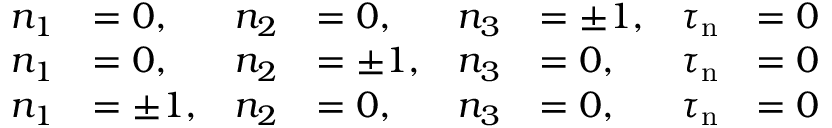Convert formula to latex. <formula><loc_0><loc_0><loc_500><loc_500>{ \begin{array} { r l r l r l r l } { n _ { 1 } } & { = 0 , } & { n _ { 2 } } & { = 0 , } & { n _ { 3 } } & { = \pm 1 , } & { \tau _ { n } } & { = 0 } \\ { n _ { 1 } } & { = 0 , } & { n _ { 2 } } & { = \pm 1 , } & { n _ { 3 } } & { = 0 , } & { \tau _ { n } } & { = 0 } \\ { n _ { 1 } } & { = \pm 1 , } & { n _ { 2 } } & { = 0 , } & { n _ { 3 } } & { = 0 , } & { \tau _ { n } } & { = 0 } \end{array} }</formula> 